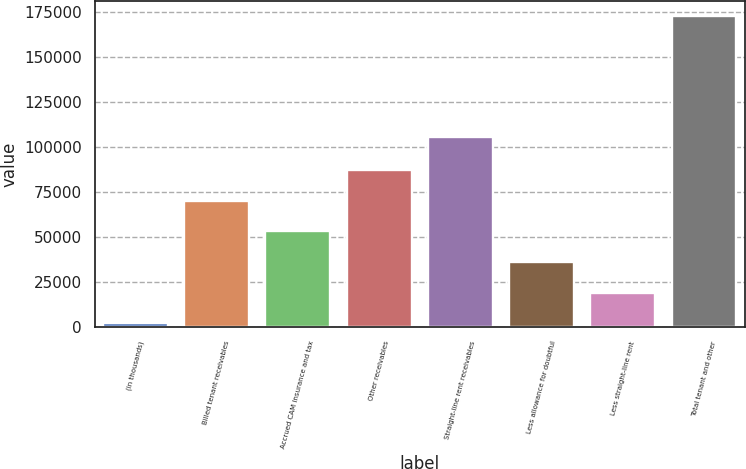Convert chart to OTSL. <chart><loc_0><loc_0><loc_500><loc_500><bar_chart><fcel>(in thousands)<fcel>Billed tenant receivables<fcel>Accrued CAM insurance and tax<fcel>Other receivables<fcel>Straight-line rent receivables<fcel>Less allowance for doubtful<fcel>Less straight-line rent<fcel>Total tenant and other<nl><fcel>2018<fcel>70154.4<fcel>53120.3<fcel>87188.5<fcel>105677<fcel>36086.2<fcel>19052.1<fcel>172359<nl></chart> 